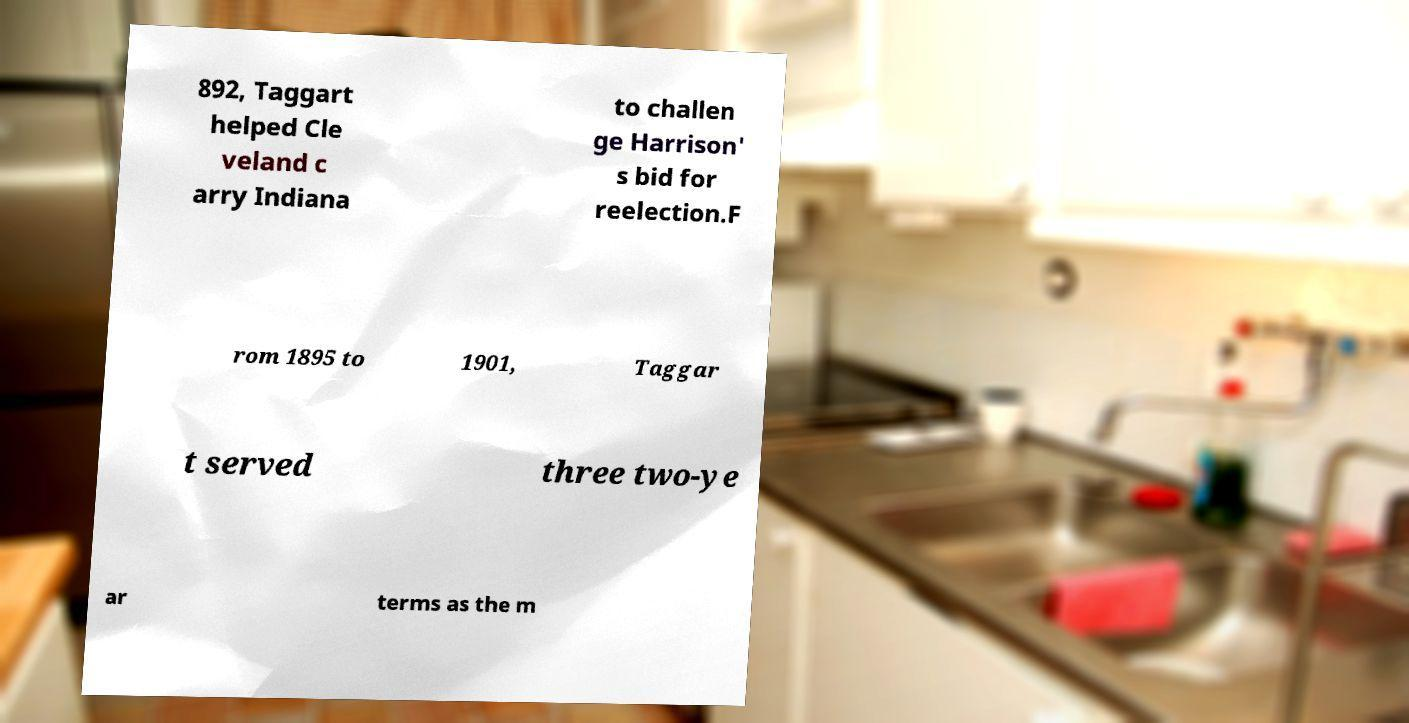Please read and relay the text visible in this image. What does it say? 892, Taggart helped Cle veland c arry Indiana to challen ge Harrison' s bid for reelection.F rom 1895 to 1901, Taggar t served three two-ye ar terms as the m 